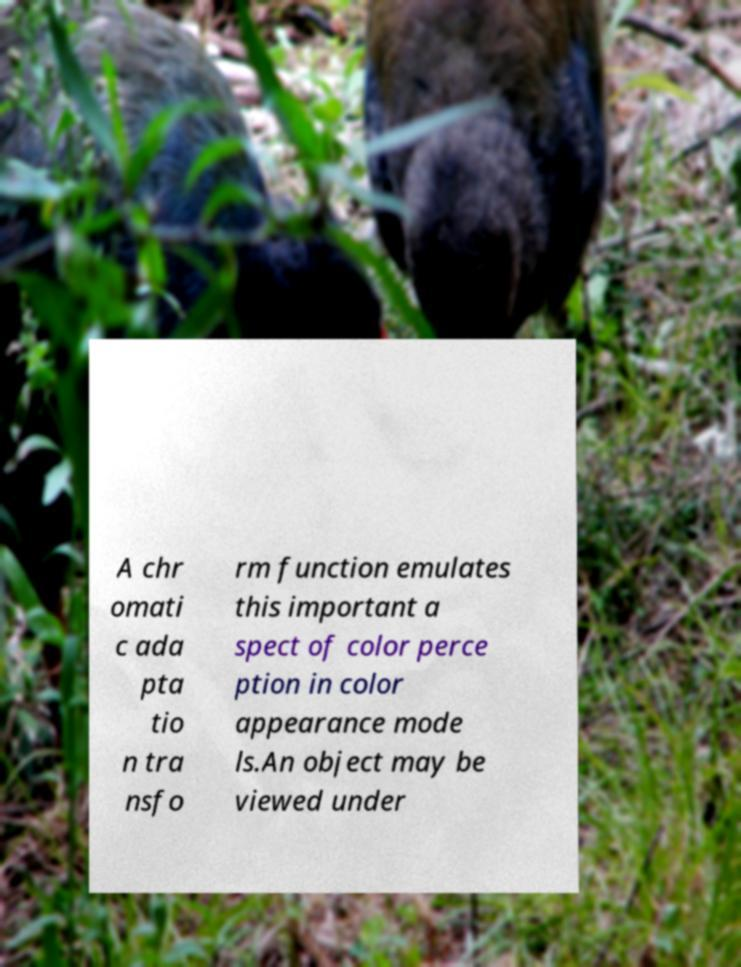For documentation purposes, I need the text within this image transcribed. Could you provide that? A chr omati c ada pta tio n tra nsfo rm function emulates this important a spect of color perce ption in color appearance mode ls.An object may be viewed under 